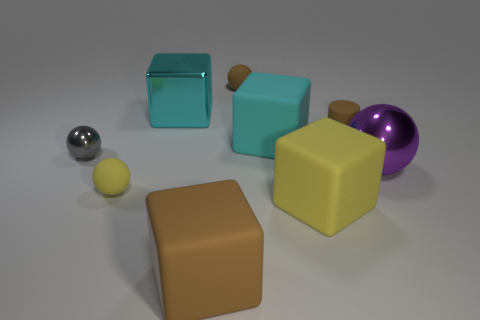Add 1 big things. How many objects exist? 10 Subtract all cubes. How many objects are left? 5 Subtract all green rubber blocks. Subtract all big yellow matte objects. How many objects are left? 8 Add 9 purple shiny objects. How many purple shiny objects are left? 10 Add 6 large shiny objects. How many large shiny objects exist? 8 Subtract 1 gray spheres. How many objects are left? 8 